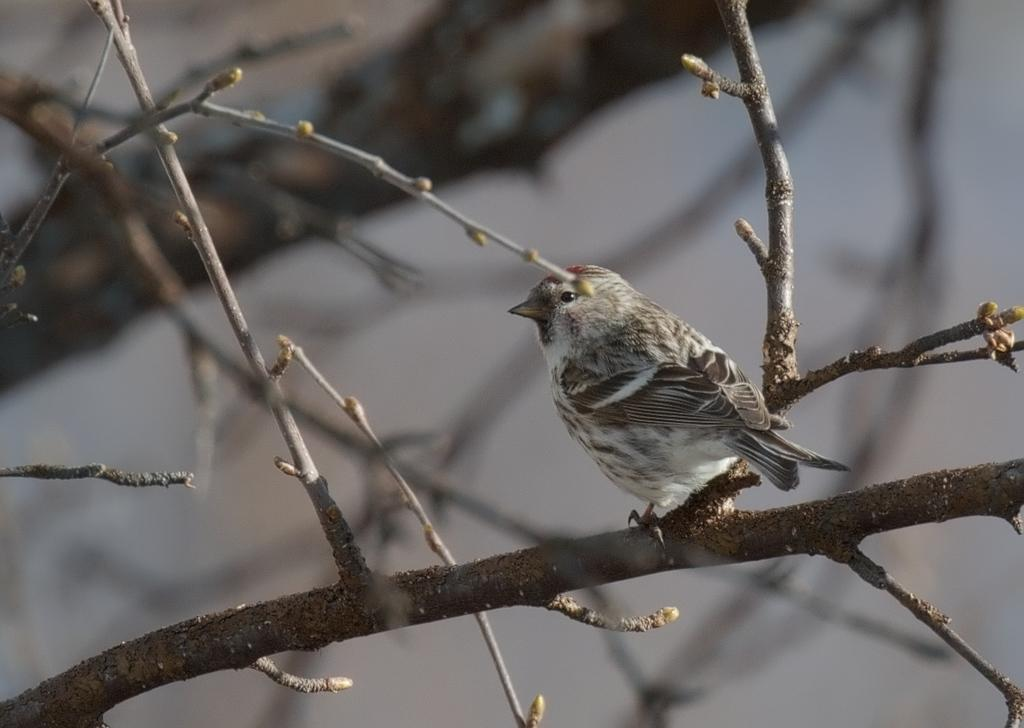What type of animal can be seen in the image? There is a bird in the image. Where is the bird located? The bird is on the branch of a tree. Can you describe the background of the image? The background of the image is blurred. What type of stem can be seen in the image? There is no stem present in the image. Is there a parcel visible in the image? There is no parcel present in the image. 